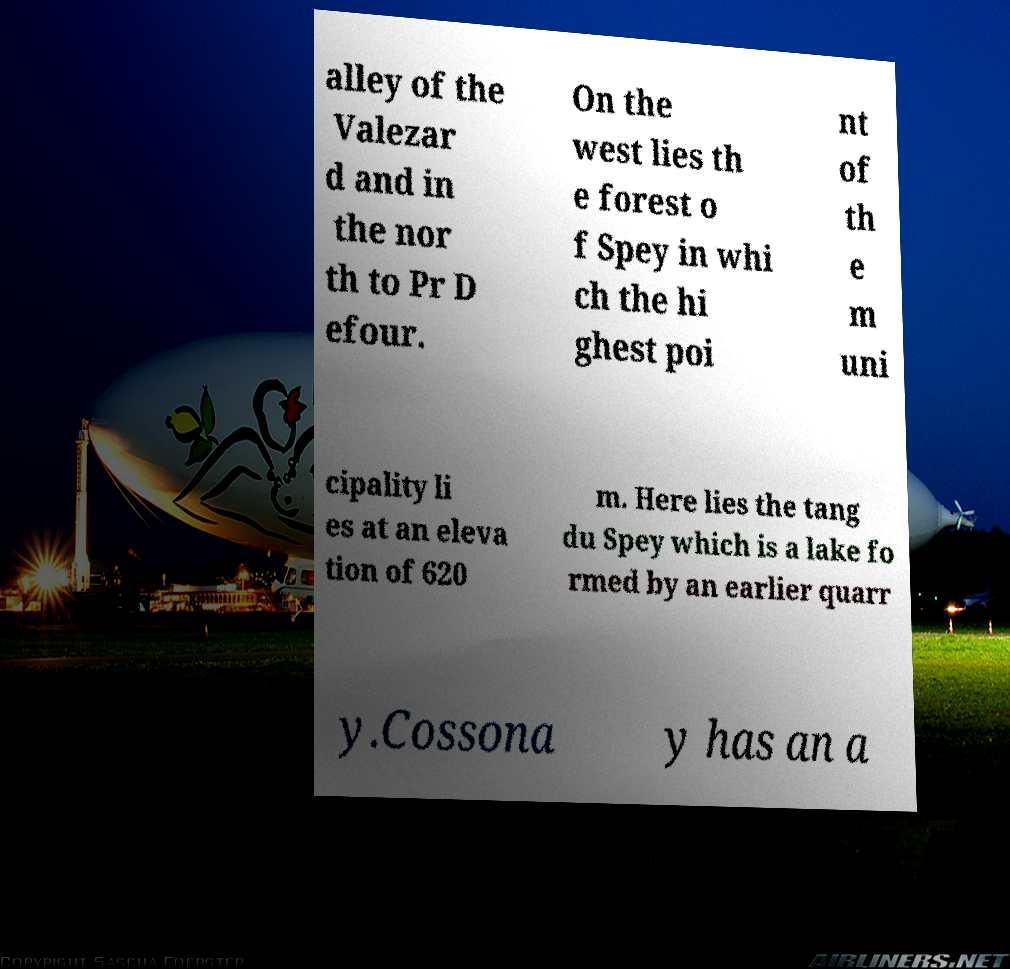I need the written content from this picture converted into text. Can you do that? alley of the Valezar d and in the nor th to Pr D efour. On the west lies th e forest o f Spey in whi ch the hi ghest poi nt of th e m uni cipality li es at an eleva tion of 620 m. Here lies the tang du Spey which is a lake fo rmed by an earlier quarr y.Cossona y has an a 